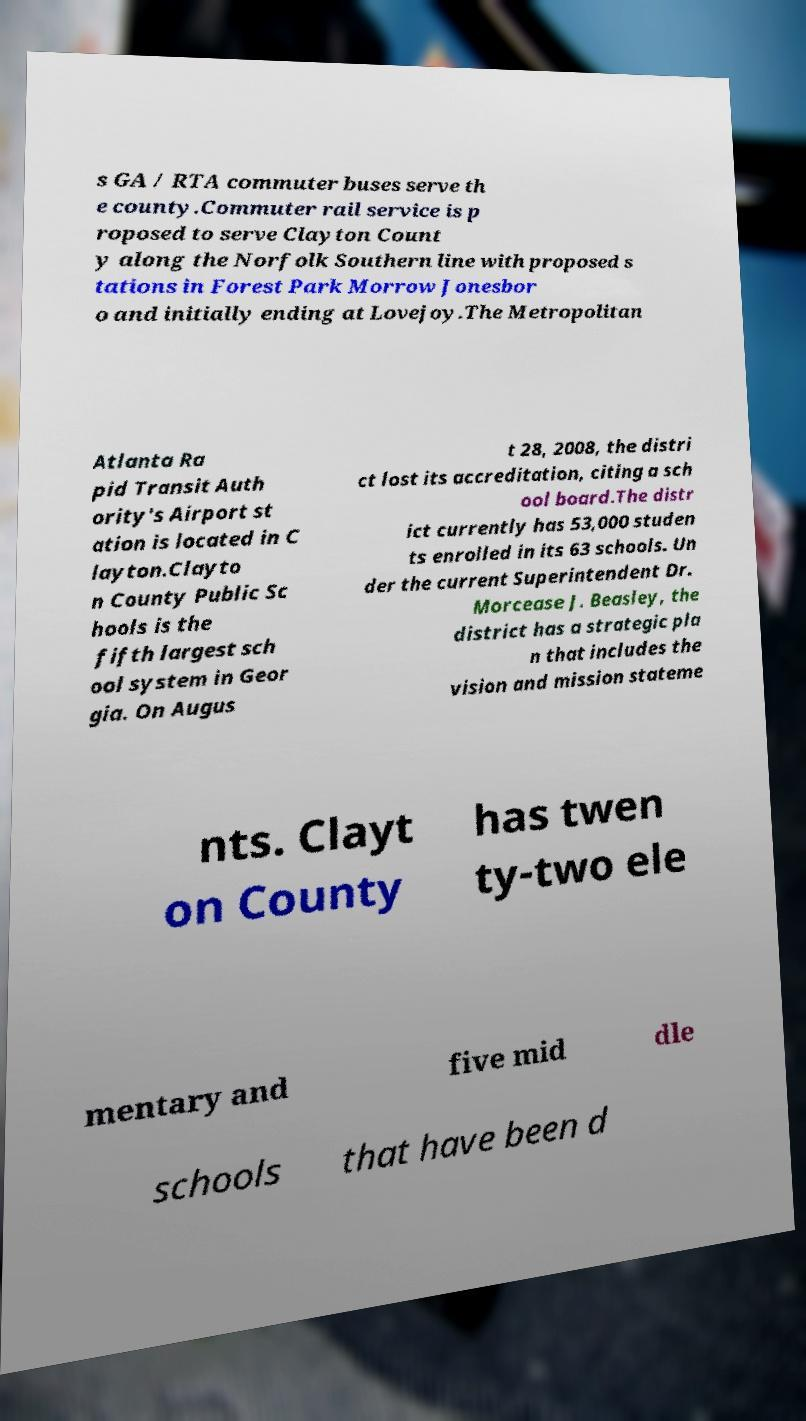Can you accurately transcribe the text from the provided image for me? s GA / RTA commuter buses serve th e county.Commuter rail service is p roposed to serve Clayton Count y along the Norfolk Southern line with proposed s tations in Forest Park Morrow Jonesbor o and initially ending at Lovejoy.The Metropolitan Atlanta Ra pid Transit Auth ority's Airport st ation is located in C layton.Clayto n County Public Sc hools is the fifth largest sch ool system in Geor gia. On Augus t 28, 2008, the distri ct lost its accreditation, citing a sch ool board.The distr ict currently has 53,000 studen ts enrolled in its 63 schools. Un der the current Superintendent Dr. Morcease J. Beasley, the district has a strategic pla n that includes the vision and mission stateme nts. Clayt on County has twen ty-two ele mentary and five mid dle schools that have been d 